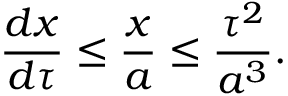<formula> <loc_0><loc_0><loc_500><loc_500>\frac { d x } { d \tau } \leq \frac { x } { a } \leq \frac { \tau ^ { 2 } } { a ^ { 3 } } .</formula> 